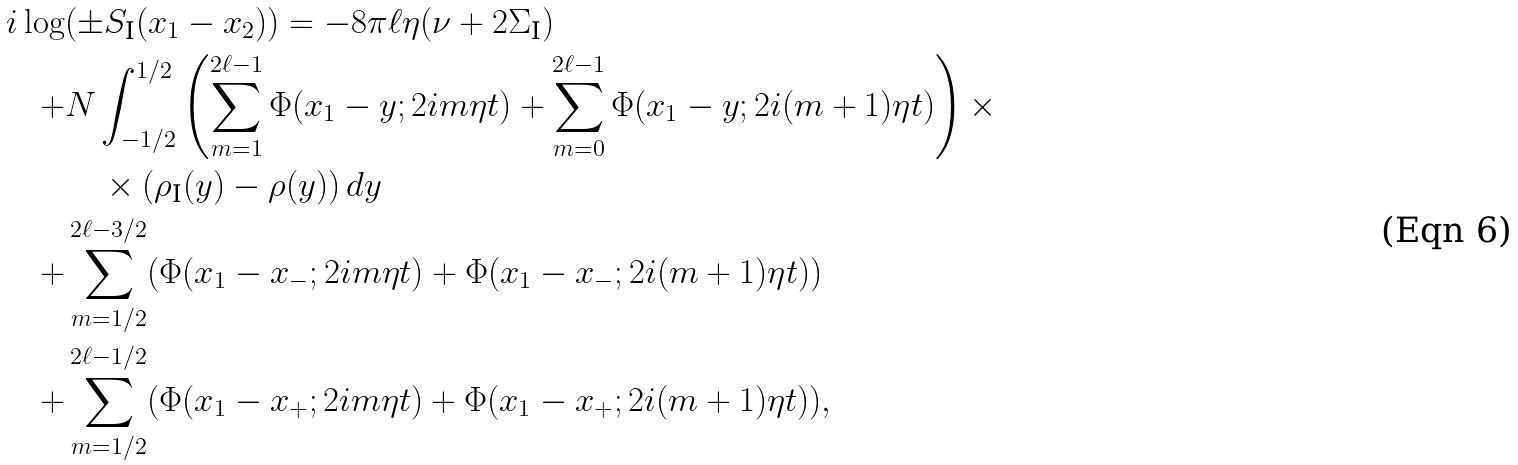Convert formula to latex. <formula><loc_0><loc_0><loc_500><loc_500>i \log & ( \pm S _ { \text  I}(x_{1} - x_{2})) =   -8\pi \ell \eta (\nu + 2\Sigma_{\text  I})\\   +&   N \int_{-1/2}^{1/2} \left(   \sum_{m=1}^{2\ell-1} \Phi(x_{1}-y; 2im\eta t) +   \sum_{m=0}^{2\ell-1} \Phi(x_{1}-y; 2i(m+1)\eta t)   \right)\times \\   &\quad \times (\rho_{\text  I}(y)-\rho(y)) \, dy\\   +&   \sum_{m=1/2}^{2\ell - 3/2}   (\Phi(x_{1}-x_{-}; 2im\eta t) + \Phi(x_{1}-x_{-}; 2i(m+1)\eta t))\\   +&   \sum_{m=1/2}^{2\ell - 1/2}   (\Phi(x_{1}-x_{+}; 2im\eta t) + \Phi(x_{1}-x_{+}; 2i(m+1)\eta t)),</formula> 